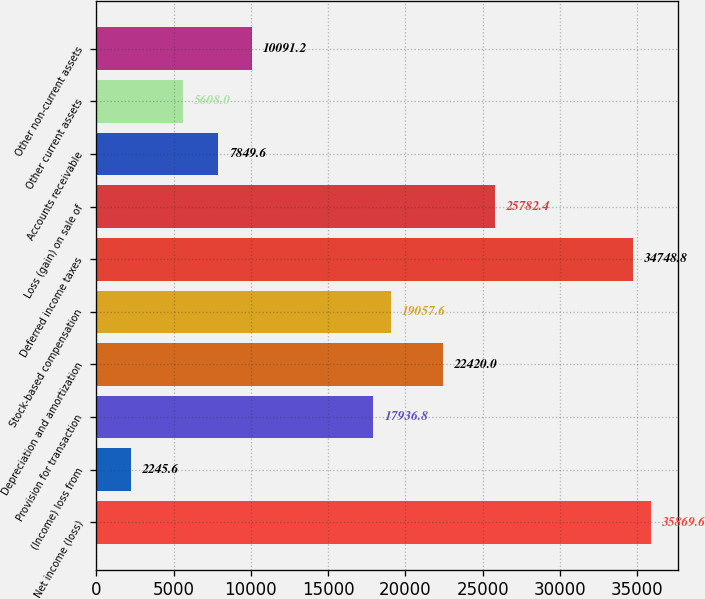<chart> <loc_0><loc_0><loc_500><loc_500><bar_chart><fcel>Net income (loss)<fcel>(Income) loss from<fcel>Provision for transaction<fcel>Depreciation and amortization<fcel>Stock-based compensation<fcel>Deferred income taxes<fcel>Loss (gain) on sale of<fcel>Accounts receivable<fcel>Other current assets<fcel>Other non-current assets<nl><fcel>35869.6<fcel>2245.6<fcel>17936.8<fcel>22420<fcel>19057.6<fcel>34748.8<fcel>25782.4<fcel>7849.6<fcel>5608<fcel>10091.2<nl></chart> 